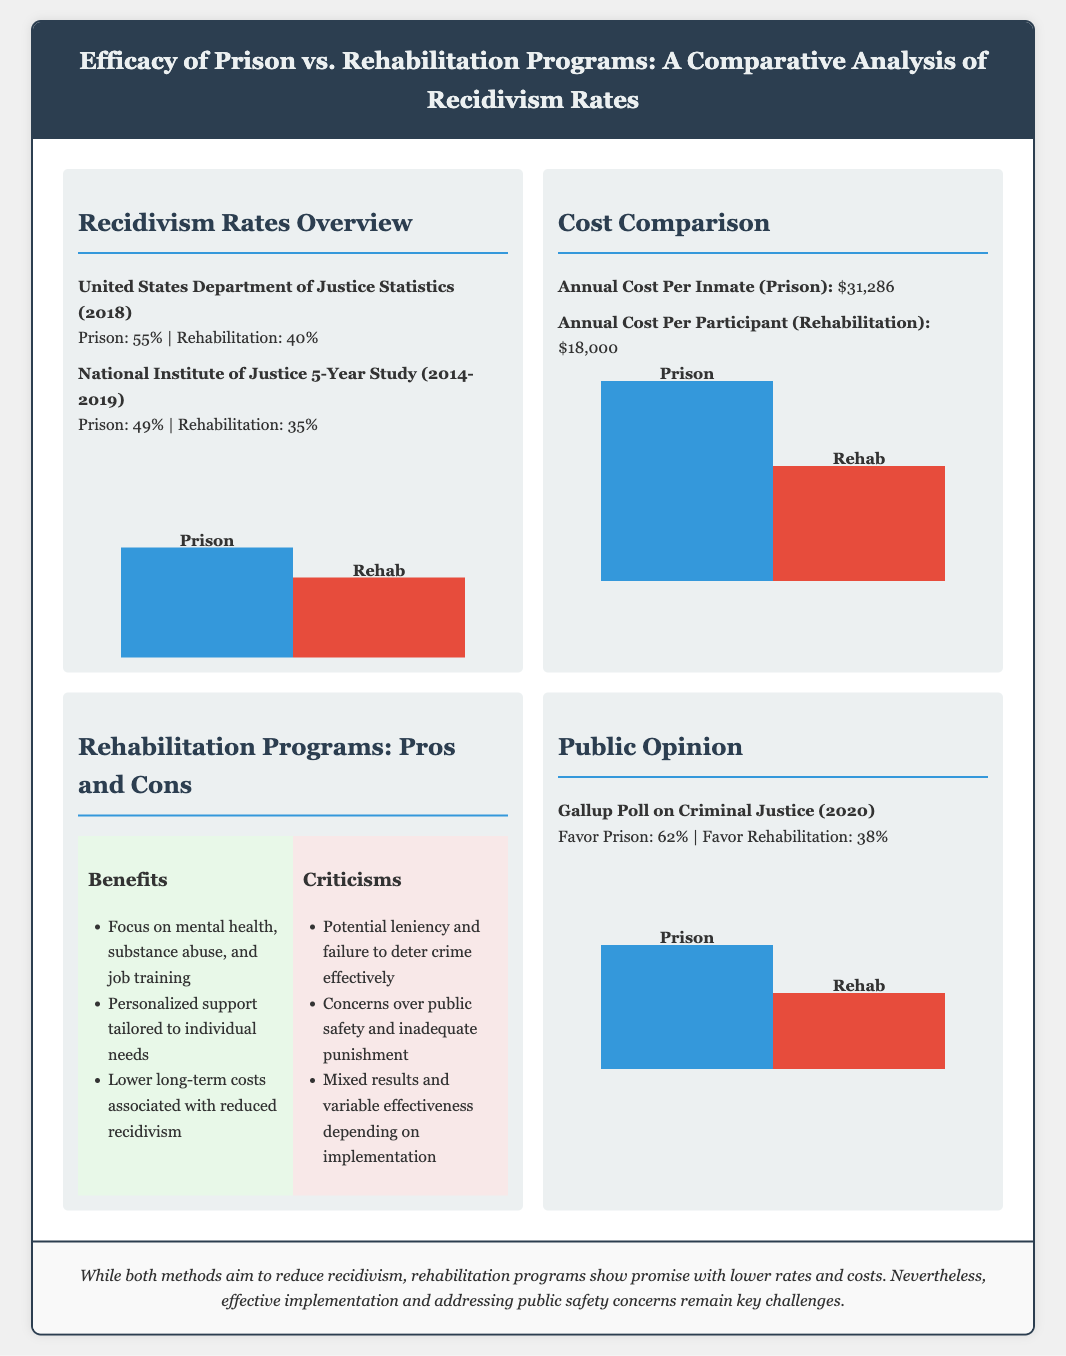What is the recidivism rate for prison according to the 2018 statistics? The document states that the recidivism rate for prison according to the 2018 statistics is 55%.
Answer: 55% What is the annual cost per inmate in prison? The annual cost per inmate in prison is stated as $31,286.
Answer: $31,286 How much lower is the recidivism rate for rehabilitation compared to prison in the 2018 statistics? The recidivism rate for rehabilitation is 40%, which is 15% lower than prison's 55%.
Answer: 15% What percentage of people favor prison according to the Gallup Poll? According to the Gallup Poll, 62% of people favor prison.
Answer: 62% What are the potential concerns over rehabilitation mentioned in the document? The document mentions concerns over public safety and inadequate punishment related to rehabilitation.
Answer: Public safety and inadequate punishment What is the conclusion regarding rehabilitation programs and recidivism? The conclusion states that rehabilitation programs show promise with lower rates and costs, but effective implementation is a challenge.
Answer: Promise with lower rates and costs What is the recidivism rate for rehabilitation according to the National Institute of Justice study? The recidivism rate for rehabilitation according to the National Institute of Justice study is 35%.
Answer: 35% Which method has a higher cost, prison or rehabilitation? The document indicates that prison has a higher cost compared to rehabilitation.
Answer: Prison What are the three benefits of rehabilitation programs listed in the document? The benefits of rehabilitation programs include focus on mental health, personalized support, and lower long-term costs.
Answer: Focus on mental health, personalized support, lower long-term costs 